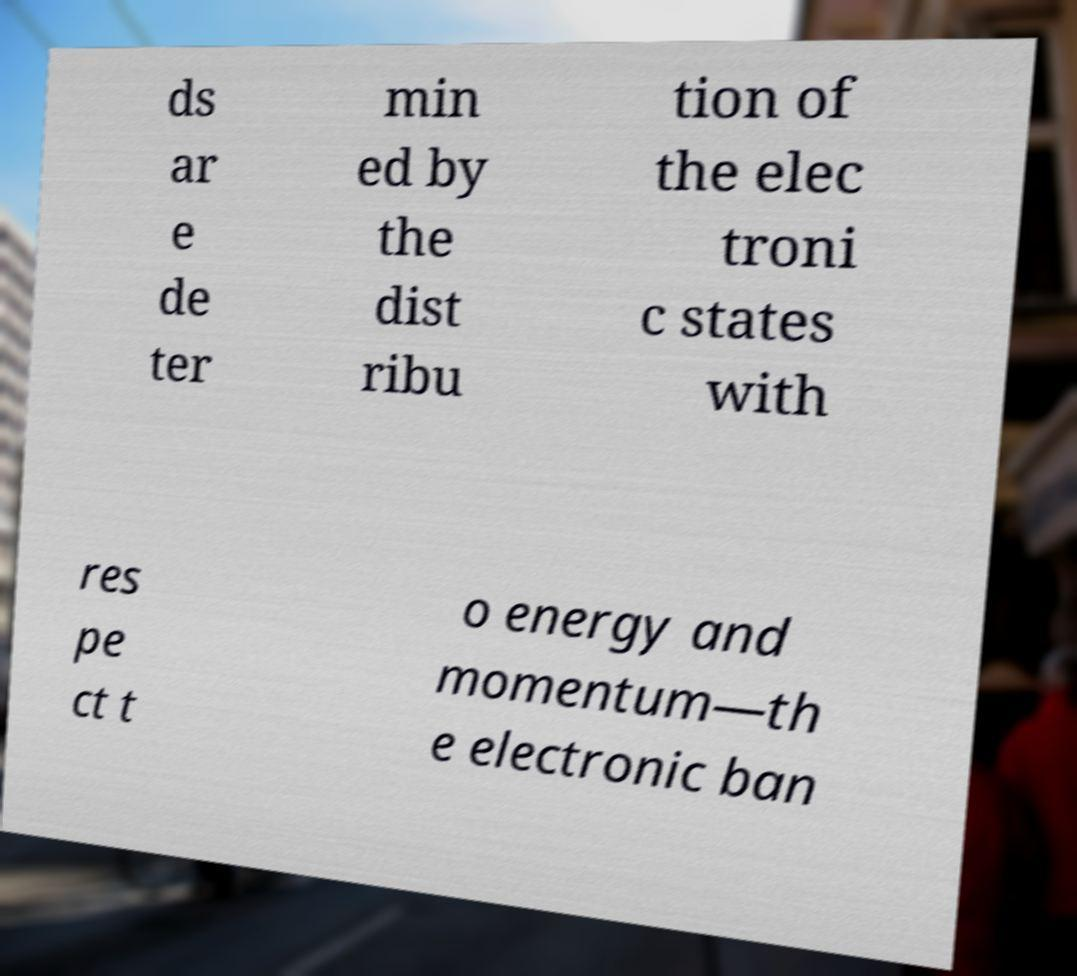Could you assist in decoding the text presented in this image and type it out clearly? ds ar e de ter min ed by the dist ribu tion of the elec troni c states with res pe ct t o energy and momentum—th e electronic ban 